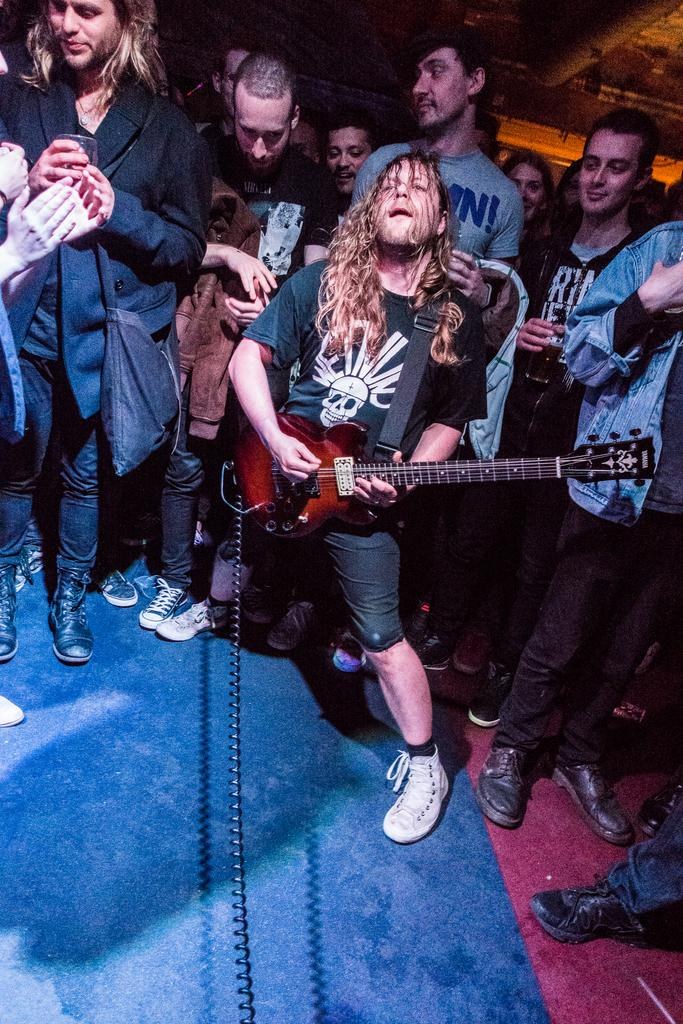What are the people in the image doing? The persons standing on the floor are likely engaged in some activity, as one person is playing a guitar. What is the floor made of? The floor has a carpet, which provides a soft surface for standing or walking. What is the uppermost part of the structure visible in the image? There is a roof visible in the image, indicating that the scene takes place indoors or under a covered area. What type of pipe is being smoked by the person playing the guitar in the image? There is no indication in the image that anyone is smoking a pipe, and therefore no such activity can be observed. 